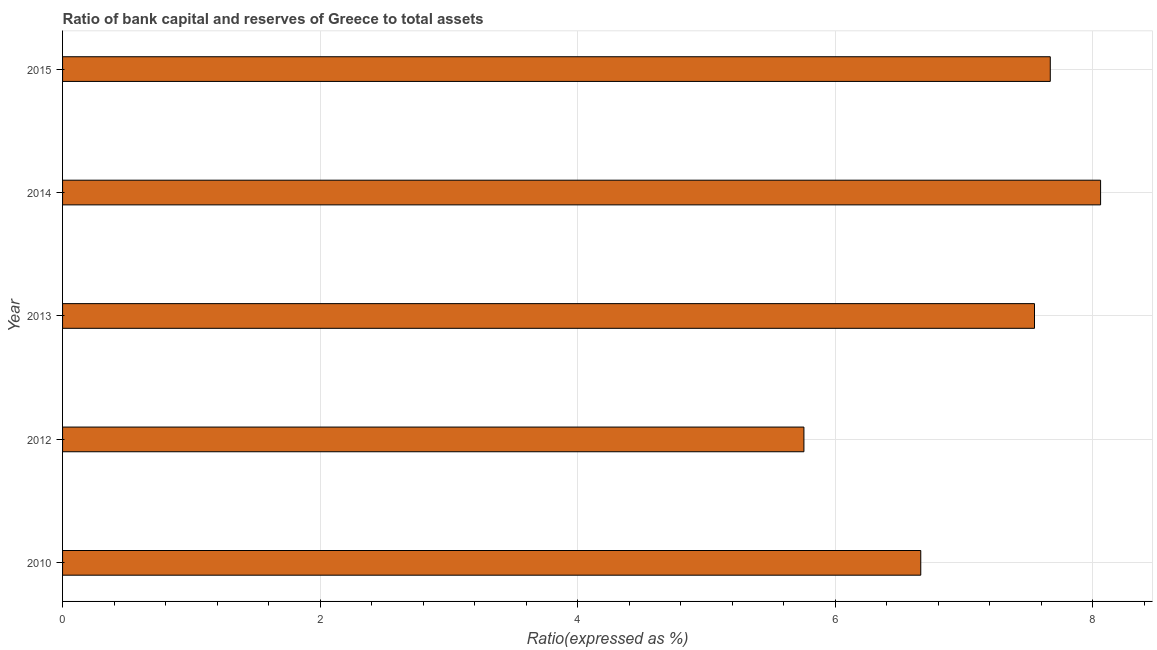What is the title of the graph?
Offer a terse response. Ratio of bank capital and reserves of Greece to total assets. What is the label or title of the X-axis?
Make the answer very short. Ratio(expressed as %). What is the label or title of the Y-axis?
Make the answer very short. Year. What is the bank capital to assets ratio in 2014?
Make the answer very short. 8.06. Across all years, what is the maximum bank capital to assets ratio?
Your answer should be very brief. 8.06. Across all years, what is the minimum bank capital to assets ratio?
Provide a succinct answer. 5.76. In which year was the bank capital to assets ratio maximum?
Provide a succinct answer. 2014. In which year was the bank capital to assets ratio minimum?
Your answer should be very brief. 2012. What is the sum of the bank capital to assets ratio?
Your response must be concise. 35.7. What is the difference between the bank capital to assets ratio in 2010 and 2012?
Your answer should be compact. 0.91. What is the average bank capital to assets ratio per year?
Offer a very short reply. 7.14. What is the median bank capital to assets ratio?
Your answer should be compact. 7.55. In how many years, is the bank capital to assets ratio greater than 6 %?
Offer a very short reply. 4. What is the ratio of the bank capital to assets ratio in 2010 to that in 2014?
Ensure brevity in your answer.  0.83. What is the difference between the highest and the second highest bank capital to assets ratio?
Keep it short and to the point. 0.39. Is the sum of the bank capital to assets ratio in 2010 and 2015 greater than the maximum bank capital to assets ratio across all years?
Offer a very short reply. Yes. In how many years, is the bank capital to assets ratio greater than the average bank capital to assets ratio taken over all years?
Ensure brevity in your answer.  3. How many years are there in the graph?
Give a very brief answer. 5. What is the difference between two consecutive major ticks on the X-axis?
Offer a terse response. 2. What is the Ratio(expressed as %) of 2010?
Your answer should be compact. 6.66. What is the Ratio(expressed as %) of 2012?
Your response must be concise. 5.76. What is the Ratio(expressed as %) in 2013?
Keep it short and to the point. 7.55. What is the Ratio(expressed as %) in 2014?
Keep it short and to the point. 8.06. What is the Ratio(expressed as %) in 2015?
Give a very brief answer. 7.67. What is the difference between the Ratio(expressed as %) in 2010 and 2012?
Give a very brief answer. 0.91. What is the difference between the Ratio(expressed as %) in 2010 and 2013?
Your answer should be compact. -0.88. What is the difference between the Ratio(expressed as %) in 2010 and 2014?
Your response must be concise. -1.4. What is the difference between the Ratio(expressed as %) in 2010 and 2015?
Provide a succinct answer. -1.01. What is the difference between the Ratio(expressed as %) in 2012 and 2013?
Your response must be concise. -1.79. What is the difference between the Ratio(expressed as %) in 2012 and 2014?
Keep it short and to the point. -2.3. What is the difference between the Ratio(expressed as %) in 2012 and 2015?
Keep it short and to the point. -1.91. What is the difference between the Ratio(expressed as %) in 2013 and 2014?
Your answer should be compact. -0.51. What is the difference between the Ratio(expressed as %) in 2013 and 2015?
Provide a short and direct response. -0.12. What is the difference between the Ratio(expressed as %) in 2014 and 2015?
Your answer should be compact. 0.39. What is the ratio of the Ratio(expressed as %) in 2010 to that in 2012?
Offer a terse response. 1.16. What is the ratio of the Ratio(expressed as %) in 2010 to that in 2013?
Keep it short and to the point. 0.88. What is the ratio of the Ratio(expressed as %) in 2010 to that in 2014?
Ensure brevity in your answer.  0.83. What is the ratio of the Ratio(expressed as %) in 2010 to that in 2015?
Provide a short and direct response. 0.87. What is the ratio of the Ratio(expressed as %) in 2012 to that in 2013?
Keep it short and to the point. 0.76. What is the ratio of the Ratio(expressed as %) in 2012 to that in 2014?
Provide a succinct answer. 0.71. What is the ratio of the Ratio(expressed as %) in 2012 to that in 2015?
Provide a short and direct response. 0.75. What is the ratio of the Ratio(expressed as %) in 2013 to that in 2014?
Your answer should be very brief. 0.94. What is the ratio of the Ratio(expressed as %) in 2014 to that in 2015?
Ensure brevity in your answer.  1.05. 